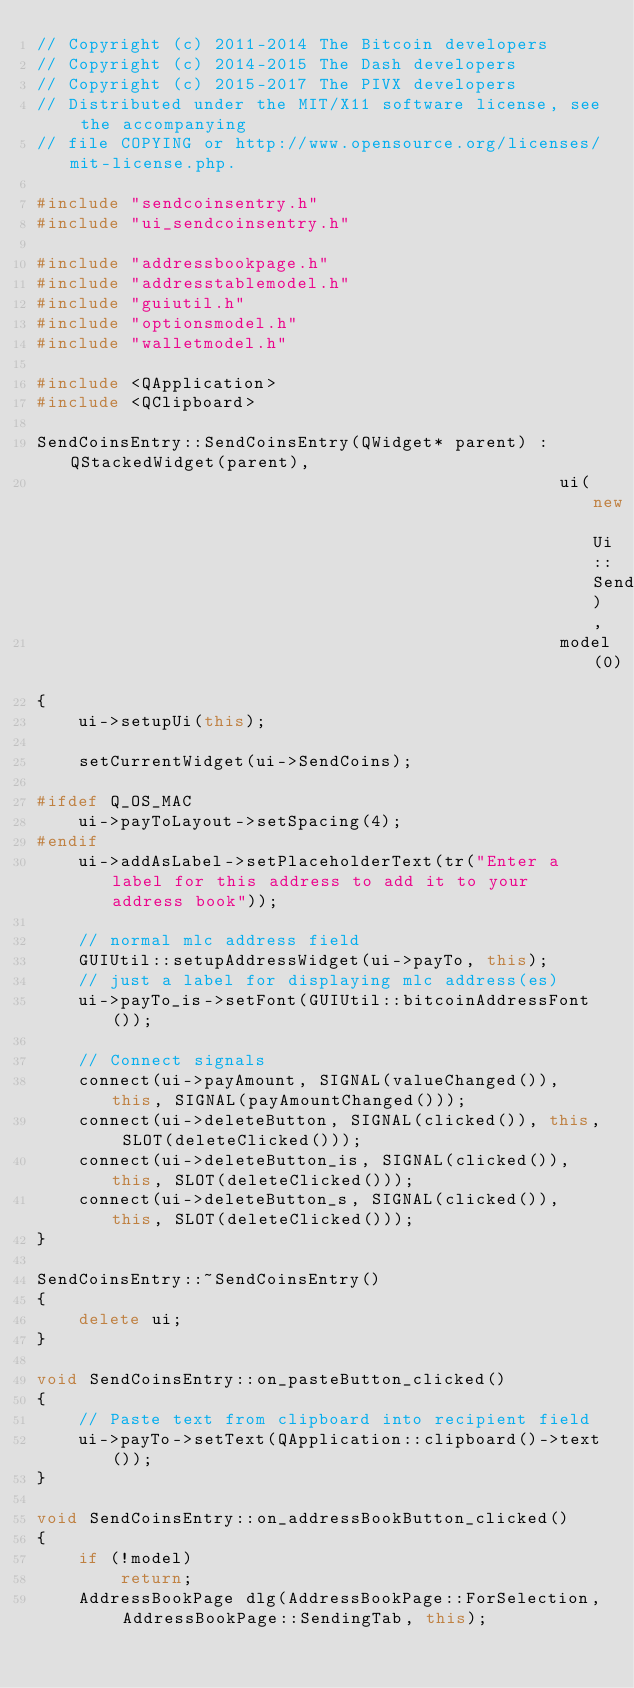Convert code to text. <code><loc_0><loc_0><loc_500><loc_500><_C++_>// Copyright (c) 2011-2014 The Bitcoin developers
// Copyright (c) 2014-2015 The Dash developers
// Copyright (c) 2015-2017 The PIVX developers
// Distributed under the MIT/X11 software license, see the accompanying
// file COPYING or http://www.opensource.org/licenses/mit-license.php.

#include "sendcoinsentry.h"
#include "ui_sendcoinsentry.h"

#include "addressbookpage.h"
#include "addresstablemodel.h"
#include "guiutil.h"
#include "optionsmodel.h"
#include "walletmodel.h"

#include <QApplication>
#include <QClipboard>

SendCoinsEntry::SendCoinsEntry(QWidget* parent) : QStackedWidget(parent),
                                                  ui(new Ui::SendCoinsEntry),
                                                  model(0)
{
    ui->setupUi(this);

    setCurrentWidget(ui->SendCoins);

#ifdef Q_OS_MAC
    ui->payToLayout->setSpacing(4);
#endif
    ui->addAsLabel->setPlaceholderText(tr("Enter a label for this address to add it to your address book"));

    // normal mlc address field
    GUIUtil::setupAddressWidget(ui->payTo, this);
    // just a label for displaying mlc address(es)
    ui->payTo_is->setFont(GUIUtil::bitcoinAddressFont());

    // Connect signals
    connect(ui->payAmount, SIGNAL(valueChanged()), this, SIGNAL(payAmountChanged()));
    connect(ui->deleteButton, SIGNAL(clicked()), this, SLOT(deleteClicked()));
    connect(ui->deleteButton_is, SIGNAL(clicked()), this, SLOT(deleteClicked()));
    connect(ui->deleteButton_s, SIGNAL(clicked()), this, SLOT(deleteClicked()));
}

SendCoinsEntry::~SendCoinsEntry()
{
    delete ui;
}

void SendCoinsEntry::on_pasteButton_clicked()
{
    // Paste text from clipboard into recipient field
    ui->payTo->setText(QApplication::clipboard()->text());
}

void SendCoinsEntry::on_addressBookButton_clicked()
{
    if (!model)
        return;
    AddressBookPage dlg(AddressBookPage::ForSelection, AddressBookPage::SendingTab, this);</code> 